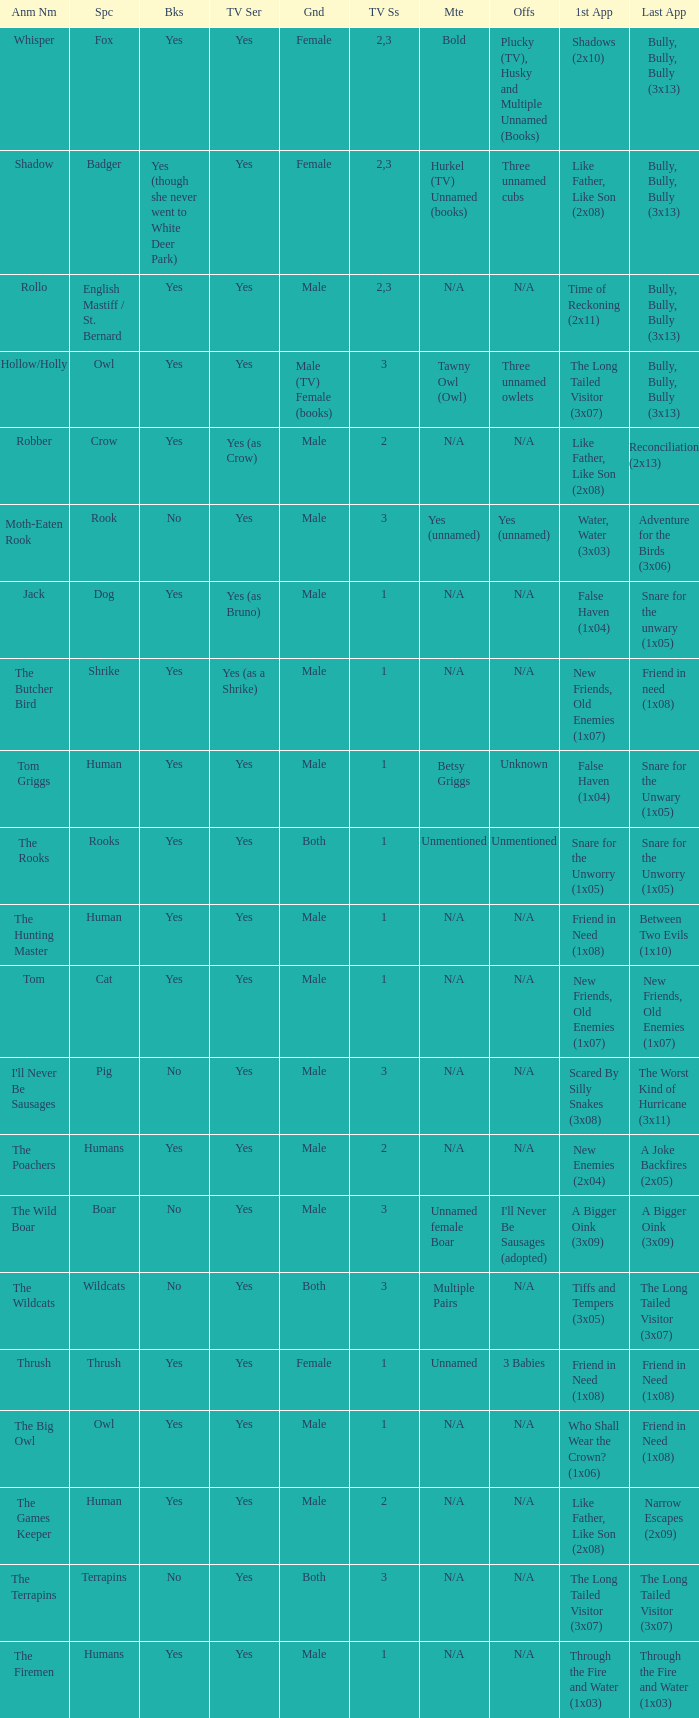What is the smallest season for a tv series with a yes and human was the species? 1.0. 